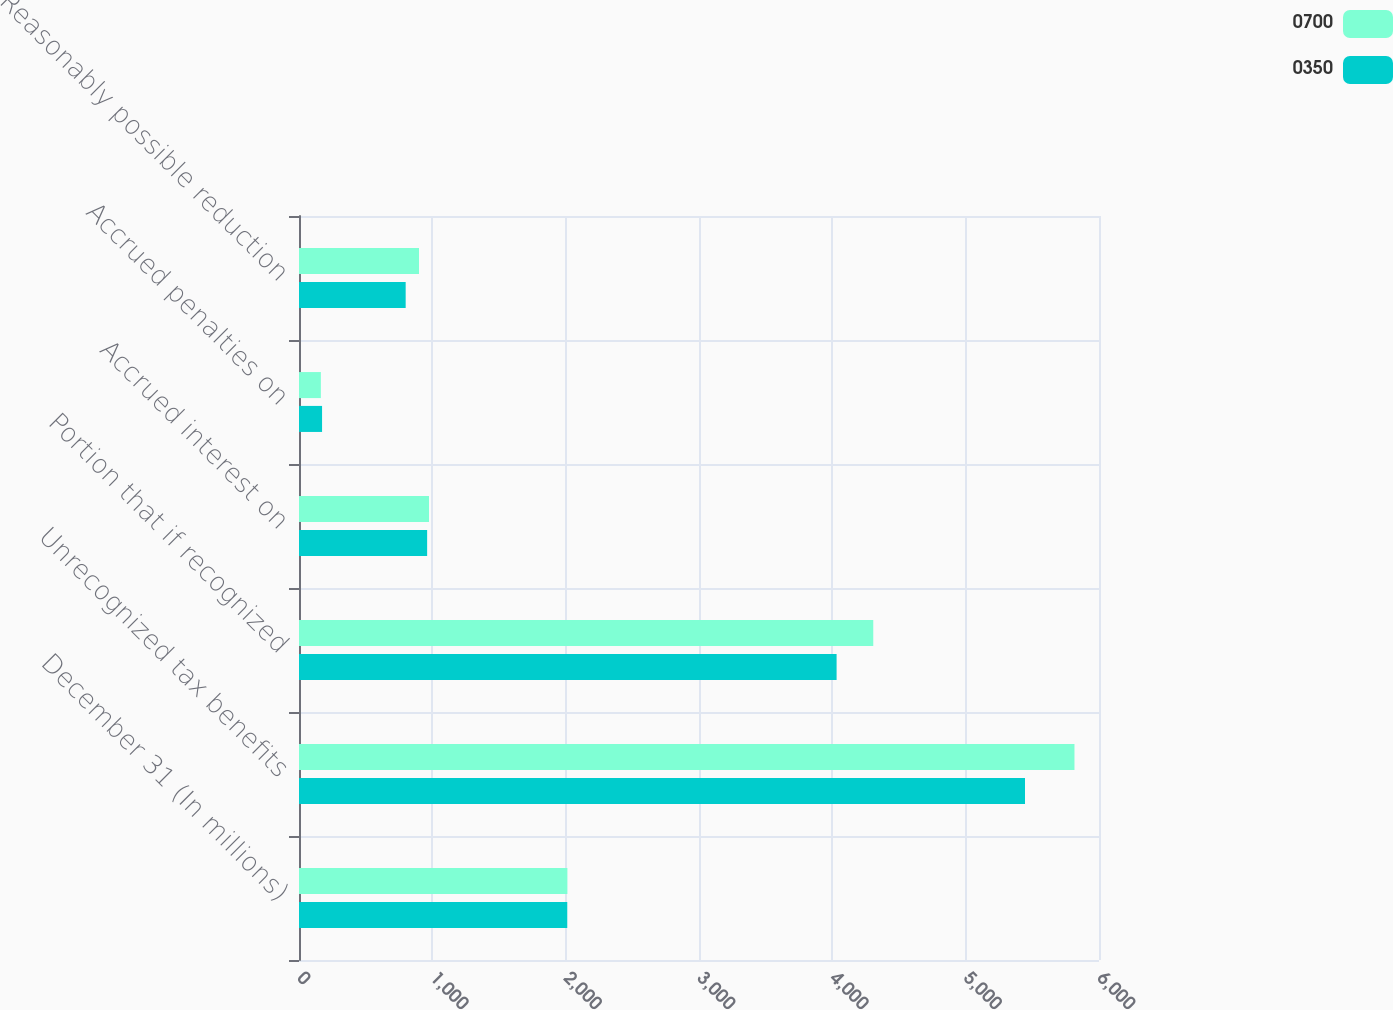Convert chart. <chart><loc_0><loc_0><loc_500><loc_500><stacked_bar_chart><ecel><fcel>December 31 (In millions)<fcel>Unrecognized tax benefits<fcel>Portion that if recognized<fcel>Accrued interest on<fcel>Accrued penalties on<fcel>Reasonably possible reduction<nl><fcel>700<fcel>2013<fcel>5816<fcel>4307<fcel>975<fcel>164<fcel>900<nl><fcel>350<fcel>2012<fcel>5445<fcel>4032<fcel>961<fcel>173<fcel>800<nl></chart> 